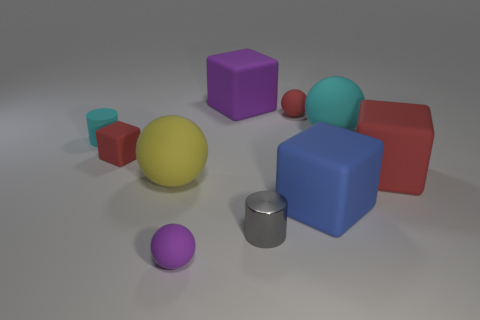Subtract all blocks. How many objects are left? 6 Add 7 cyan matte cylinders. How many cyan matte cylinders are left? 8 Add 3 tiny objects. How many tiny objects exist? 8 Subtract 1 cyan balls. How many objects are left? 9 Subtract all tiny cyan matte things. Subtract all large blue blocks. How many objects are left? 8 